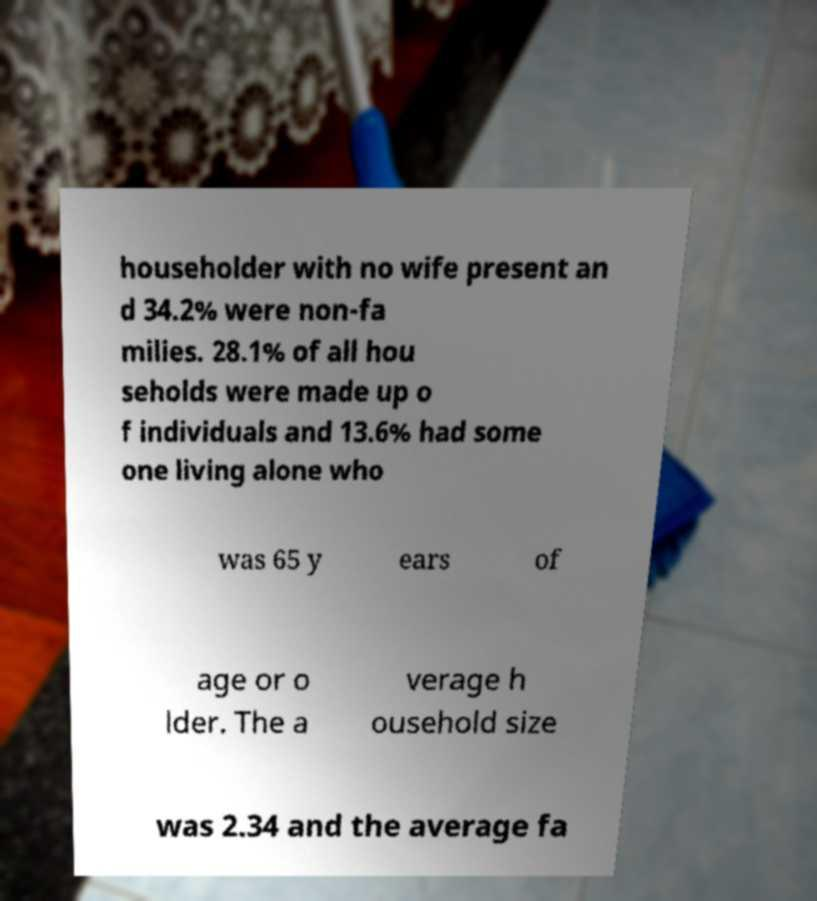Can you accurately transcribe the text from the provided image for me? householder with no wife present an d 34.2% were non-fa milies. 28.1% of all hou seholds were made up o f individuals and 13.6% had some one living alone who was 65 y ears of age or o lder. The a verage h ousehold size was 2.34 and the average fa 